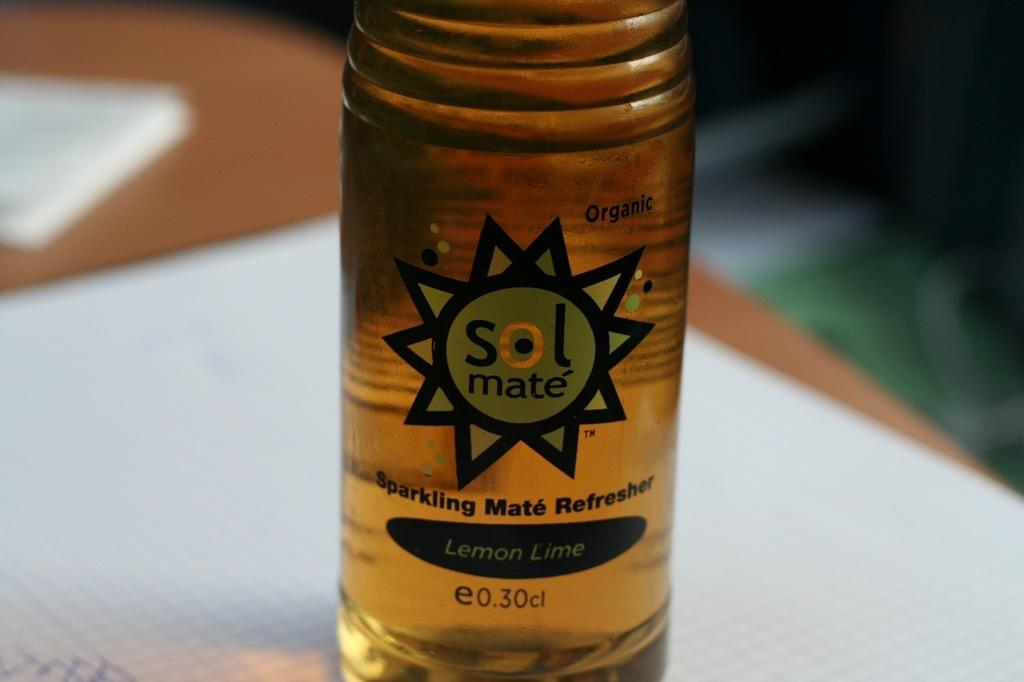Provide a one-sentence caption for the provided image. A beverage, called sol mate, is lemon-lime flavor. 